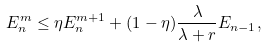Convert formula to latex. <formula><loc_0><loc_0><loc_500><loc_500>E ^ { m } _ { n } \leq \eta E ^ { m + 1 } _ { n } + ( 1 - \eta ) \frac { \lambda } { \lambda + r } E _ { n - 1 } ,</formula> 